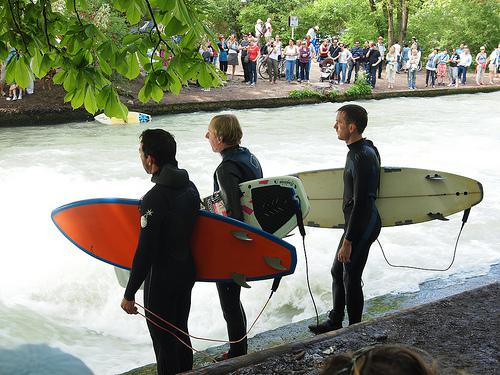Question: what is orange?
Choices:
A. A surfboard.
B. The bathing suit.
C. A towel.
D. An umbrella.
Answer with the letter. Answer: A Question: where are the surfers standing?
Choices:
A. In the water.
B. In the grass.
C. At the edge of the water.
D. On the sand.
Answer with the letter. Answer: C Question: what is hanging over the surfer's heads?
Choices:
A. Nothing.
B. Leaves and branches.
C. Souvenirs.
D. Surfboards.
Answer with the letter. Answer: B Question: how many surfers are visible?
Choices:
A. One.
B. Three.
C. Two.
D. None.
Answer with the letter. Answer: B Question: why are we looking at the back of the surfers?
Choices:
A. The surfers are running into the water.
B. Because that is the perspective of the photographer.
C. The surfers don't want their picture taken.
D. The see the design on the back of their wetsuits.
Answer with the letter. Answer: B 